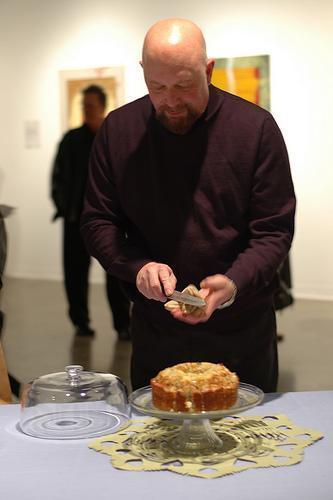How many people are in the picture?
Give a very brief answer. 2. 